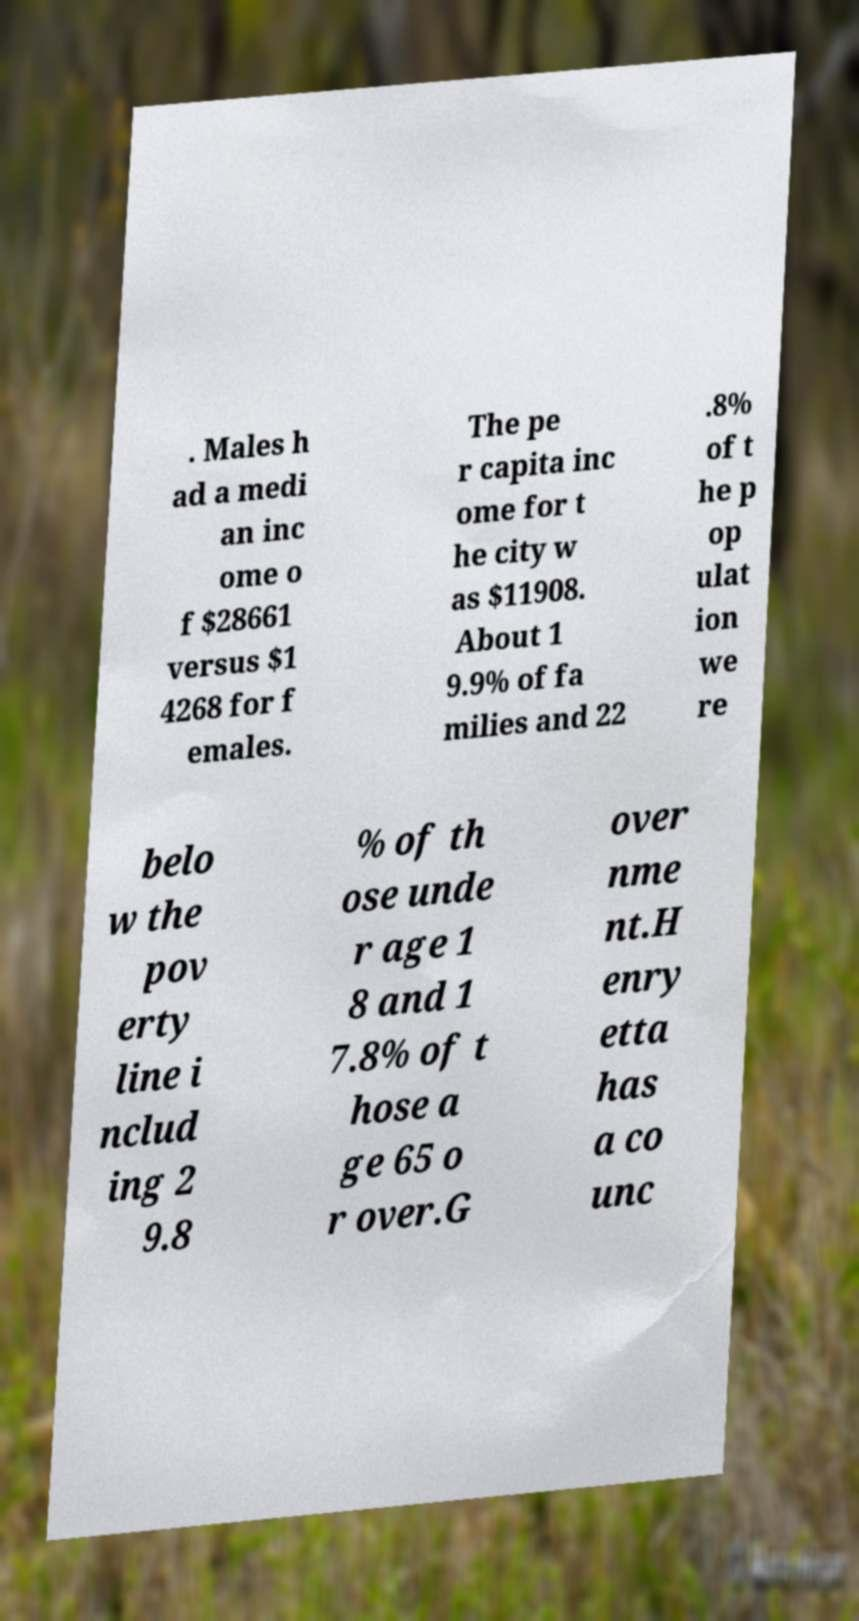Could you extract and type out the text from this image? . Males h ad a medi an inc ome o f $28661 versus $1 4268 for f emales. The pe r capita inc ome for t he city w as $11908. About 1 9.9% of fa milies and 22 .8% of t he p op ulat ion we re belo w the pov erty line i nclud ing 2 9.8 % of th ose unde r age 1 8 and 1 7.8% of t hose a ge 65 o r over.G over nme nt.H enry etta has a co unc 